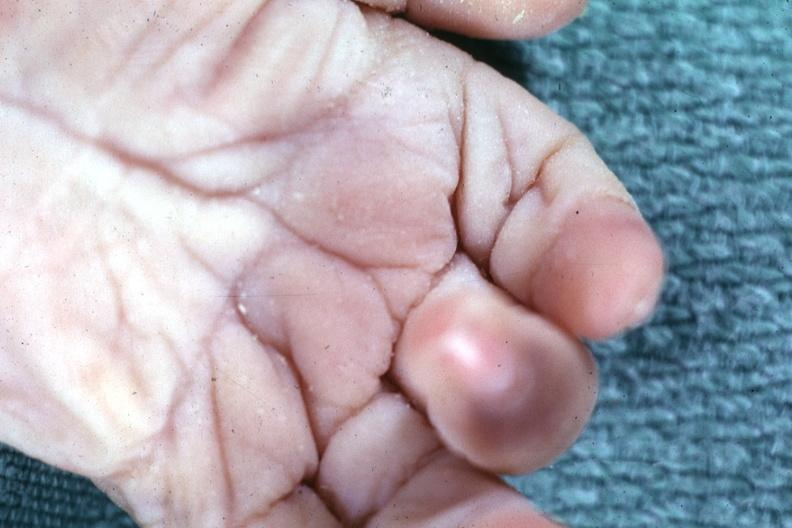s hand present?
Answer the question using a single word or phrase. Yes 